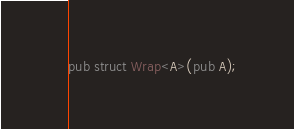Convert code to text. <code><loc_0><loc_0><loc_500><loc_500><_Rust_>pub struct Wrap<A>(pub A);
</code> 